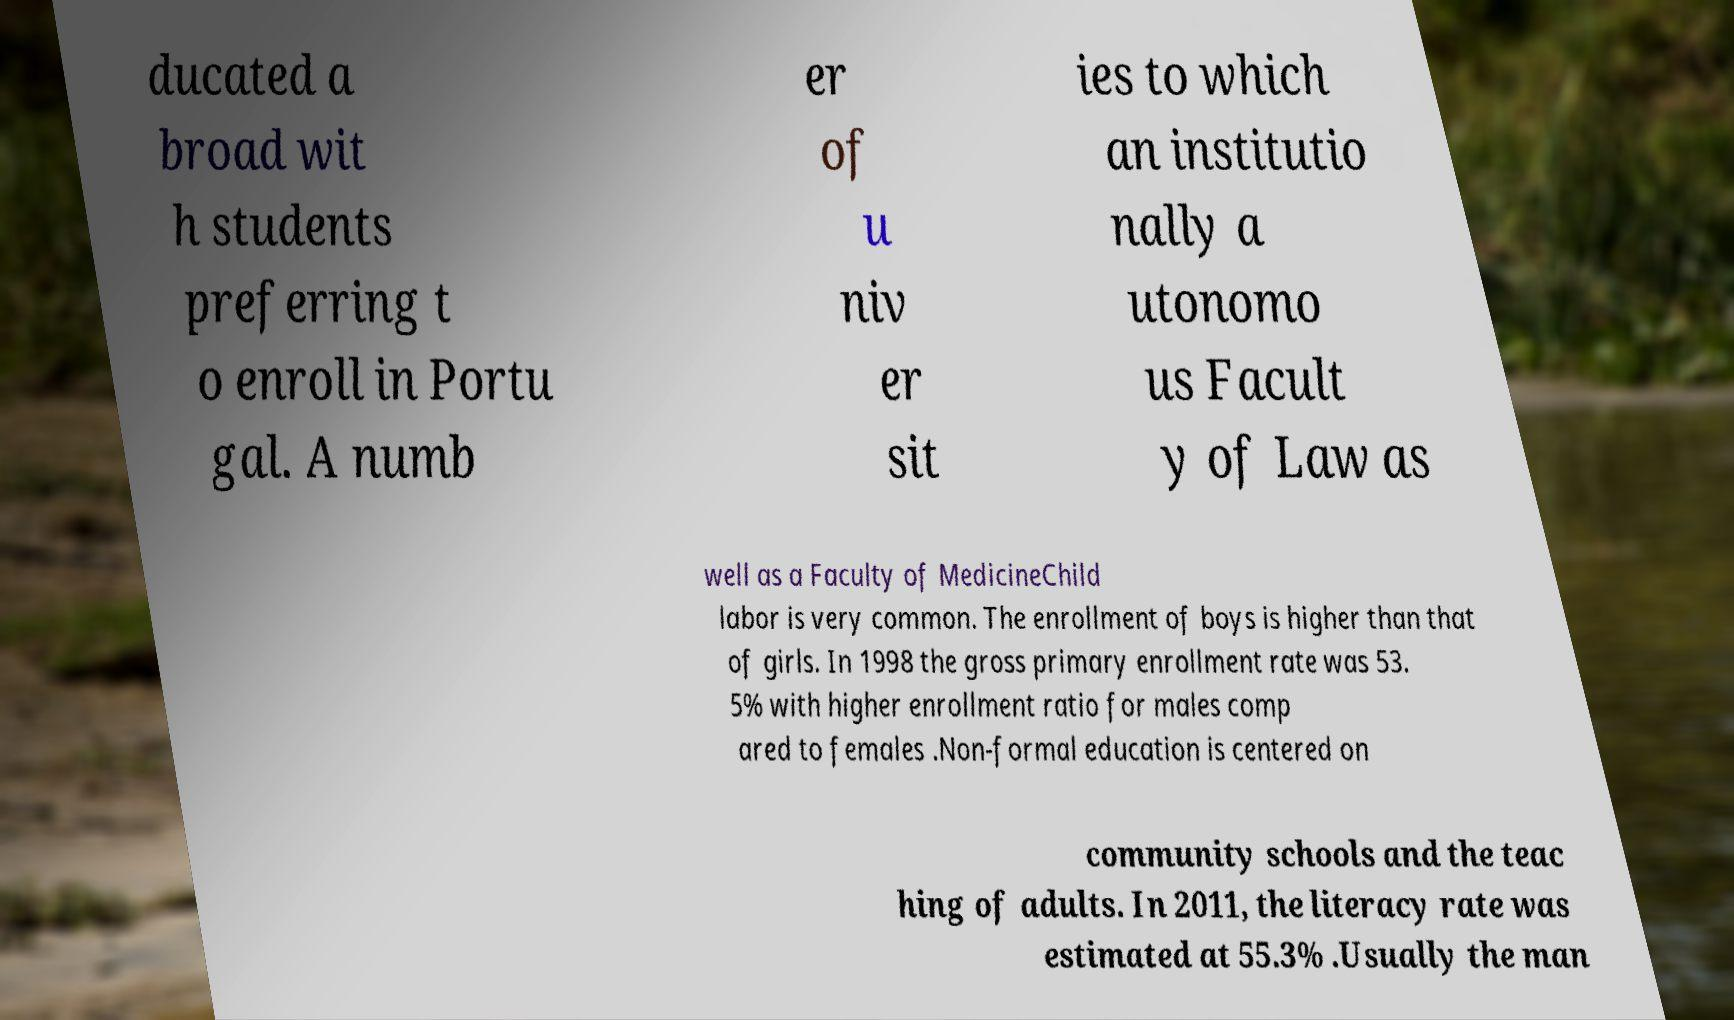Could you assist in decoding the text presented in this image and type it out clearly? ducated a broad wit h students preferring t o enroll in Portu gal. A numb er of u niv er sit ies to which an institutio nally a utonomo us Facult y of Law as well as a Faculty of MedicineChild labor is very common. The enrollment of boys is higher than that of girls. In 1998 the gross primary enrollment rate was 53. 5% with higher enrollment ratio for males comp ared to females .Non-formal education is centered on community schools and the teac hing of adults. In 2011, the literacy rate was estimated at 55.3% .Usually the man 